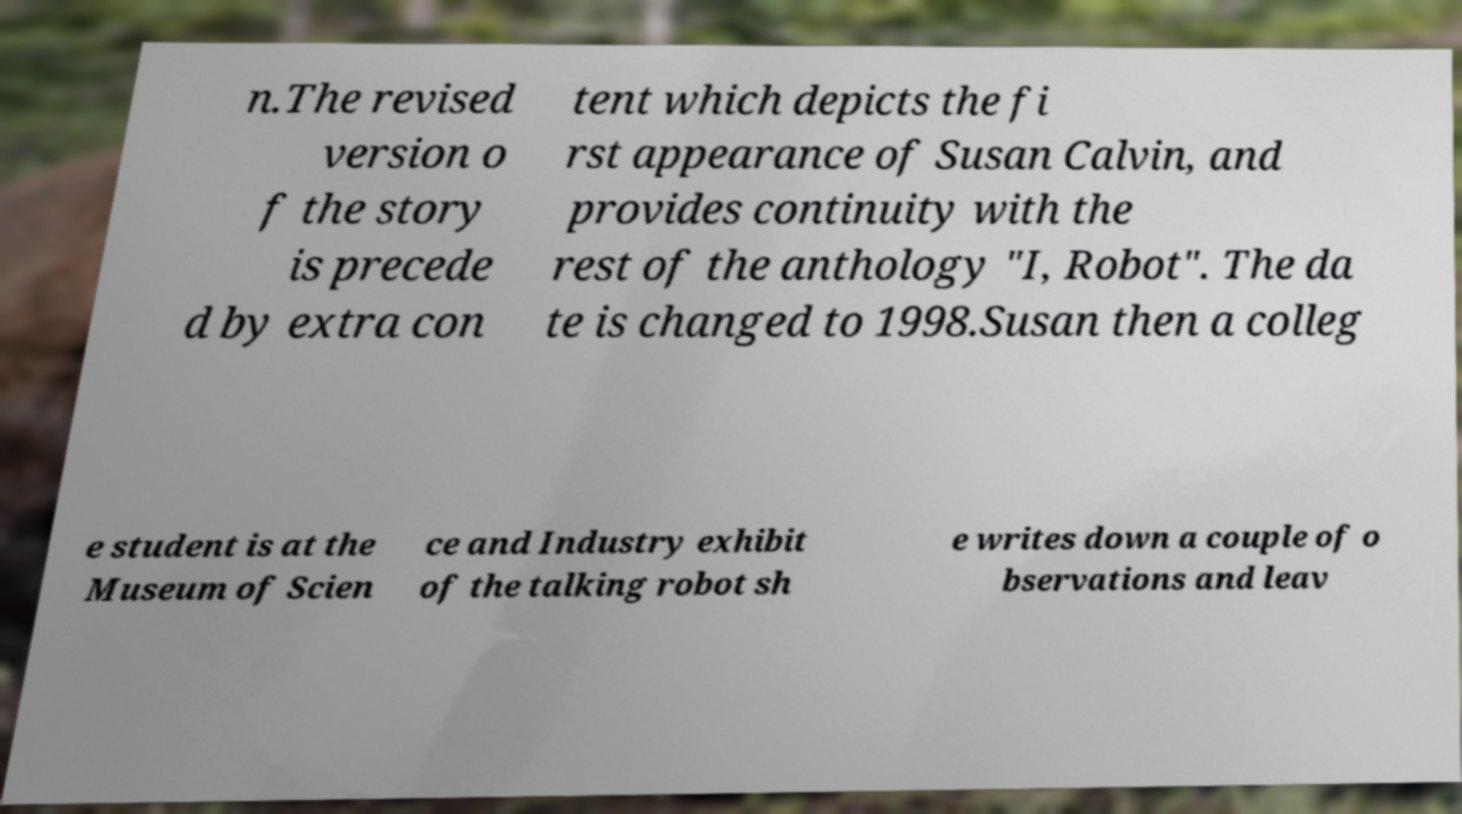Can you accurately transcribe the text from the provided image for me? n.The revised version o f the story is precede d by extra con tent which depicts the fi rst appearance of Susan Calvin, and provides continuity with the rest of the anthology "I, Robot". The da te is changed to 1998.Susan then a colleg e student is at the Museum of Scien ce and Industry exhibit of the talking robot sh e writes down a couple of o bservations and leav 